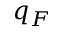<formula> <loc_0><loc_0><loc_500><loc_500>q _ { F }</formula> 